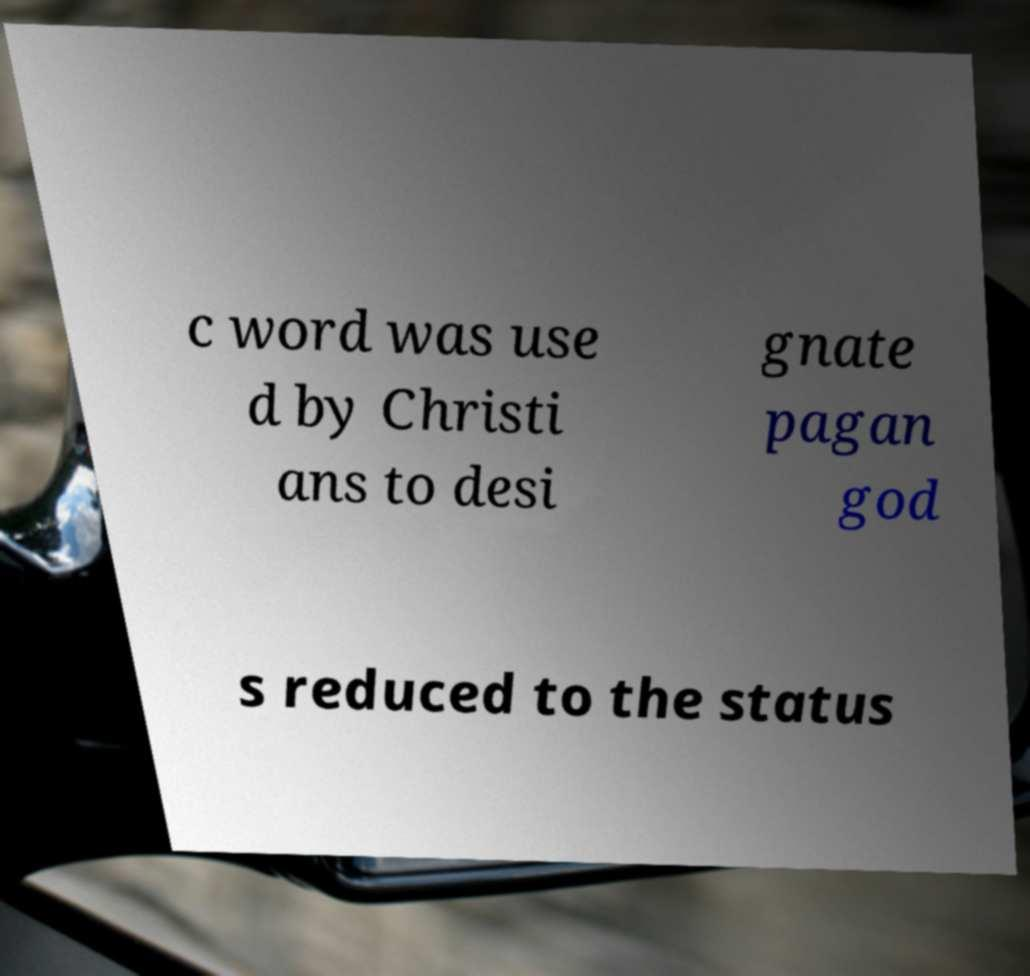Please read and relay the text visible in this image. What does it say? c word was use d by Christi ans to desi gnate pagan god s reduced to the status 